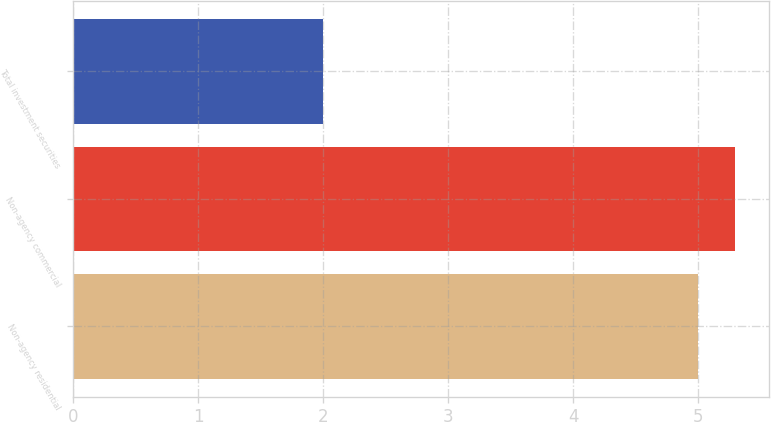<chart> <loc_0><loc_0><loc_500><loc_500><bar_chart><fcel>Non-agency residential<fcel>Non-agency commercial<fcel>Total investment securities<nl><fcel>5<fcel>5.3<fcel>2<nl></chart> 